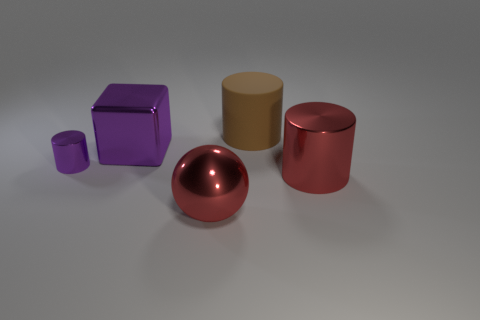Is there anything else that is the same size as the purple metallic cylinder?
Keep it short and to the point. No. What size is the shiny cube that is the same color as the tiny shiny object?
Your answer should be compact. Large. Are there any other things that have the same material as the brown object?
Your response must be concise. No. Are there any other things that have the same color as the matte thing?
Your answer should be very brief. No. What is the shape of the large purple shiny thing?
Ensure brevity in your answer.  Cube. There is a tiny thing that is made of the same material as the sphere; what is its color?
Provide a short and direct response. Purple. Is the number of large rubber cylinders greater than the number of large green cylinders?
Your response must be concise. Yes. Are any tiny objects visible?
Keep it short and to the point. Yes. What is the shape of the purple shiny object that is on the right side of the purple thing that is to the left of the big purple block?
Give a very brief answer. Cube. What number of objects are metallic balls or big shiny things right of the big sphere?
Your answer should be very brief. 2. 